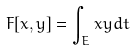<formula> <loc_0><loc_0><loc_500><loc_500>F [ x , y ] = \int _ { E } x y d t</formula> 